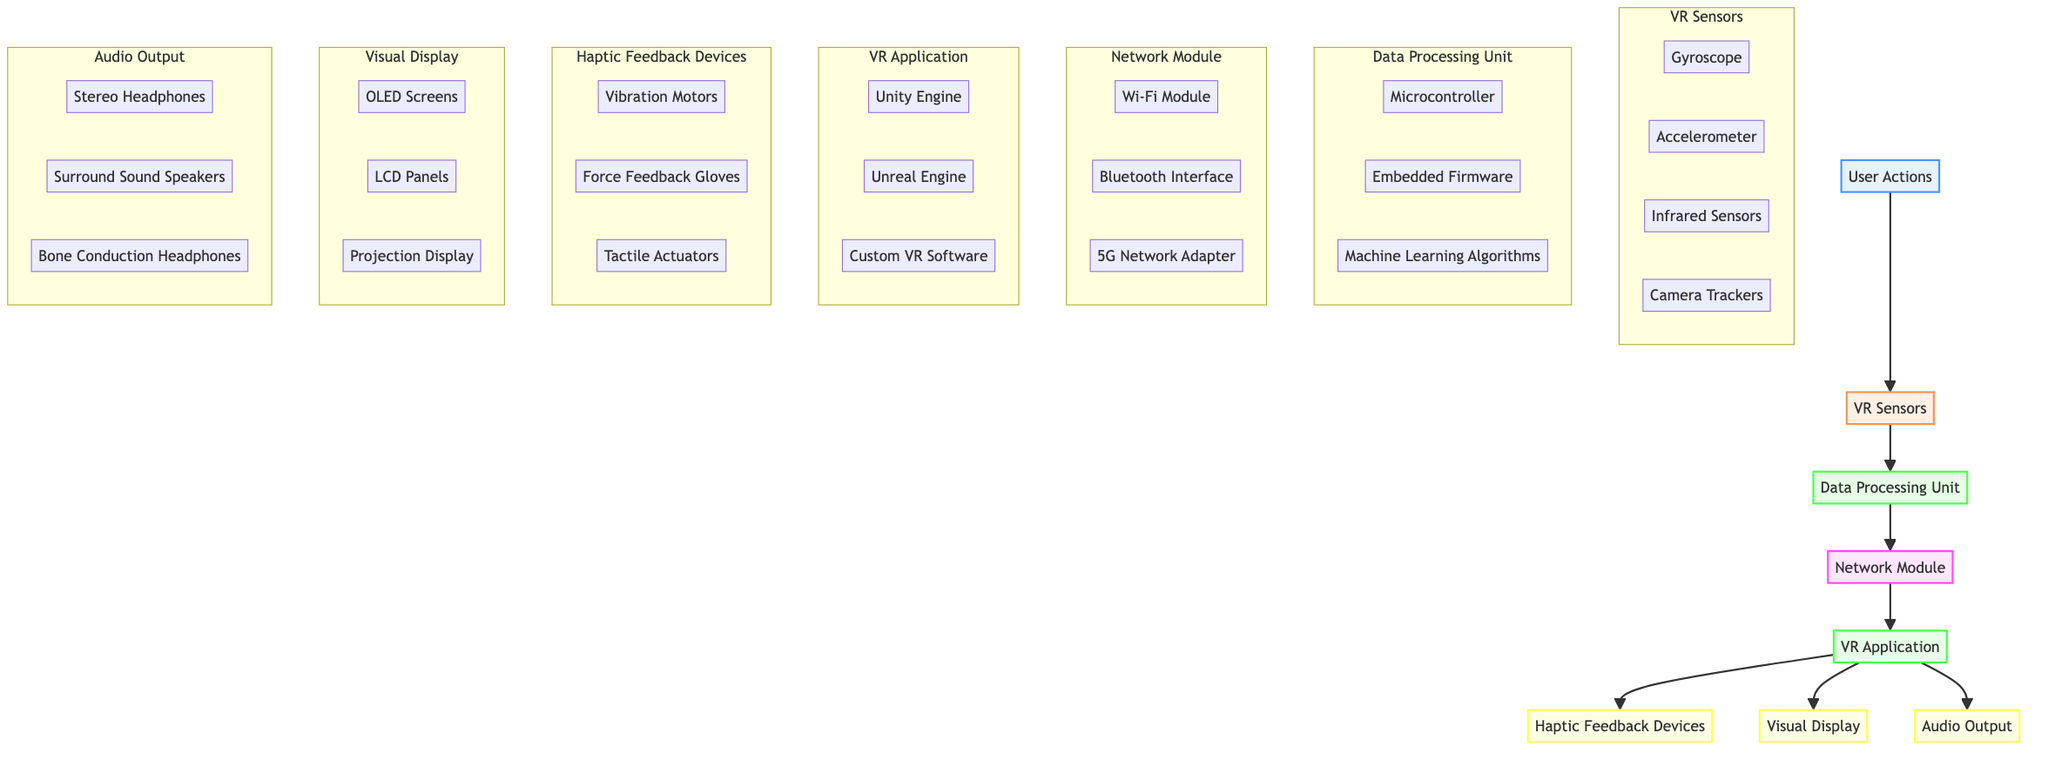What's the total number of nodes in the diagram? The diagram displays a total of 8 distinct nodes: User Actions, VR Sensors, Data Processing Unit, Network Module, VR Application, Haptic Feedback Devices, Visual Display, and Audio Output.
Answer: 8 What is the primary function of the "VR Sensors" node? According to the diagram, the "VR Sensors" node captures physical movements and gestures. This node is crucial for detecting user actions in a VR environment.
Answer: Captures physical movements How many components are there in the "Network Module"? The "Network Module" consists of three components: Wi-Fi Module, Bluetooth Interface, and 5G Network Adapter, as indicated within the node in the diagram.
Answer: 3 Which output devices are directly affected by the "VR Application"? The "VR Application" node connects directly to three output devices: Haptic Feedback Devices, Visual Display, and Audio Output, indicating that it influences all these outputs.
Answer: Haptic Feedback Devices, Visual Display, Audio Output What kind of data processing is included in the "Data Processing Unit"? The "Data Processing Unit" node includes three types of data processing components: Microcontroller, Embedded Firmware, and Machine Learning Algorithms, which are responsible for interpreting data from VR sensors.
Answer: Microcontroller, Embedded Firmware, Machine Learning Algorithms How do user actions initiate the feedback loop in the diagram? User actions are the initiating input, which flows to the "VR Sensors", indicating that these actions trigger the entire feedback loop by being the first node in the sequence.
Answer: Through VR Sensors What type of feedback does the "Haptic Feedback Devices" node provide? The diagram specifies that the "Haptic Feedback Devices" produce physical feedback, which serves to enhance the user's experience through tactile sensations in response to their actions.
Answer: Physical feedback How does the "Network Module" contribute to the user interaction feedback loop? The "Network Module" is responsible for transferring processed data between devices, which is essential for maintaining communication and real-time updates within the VR environment.
Answer: Transfers processed data What are the components listed under "Visual Display"? The "Visual Display" node includes components like OLED Screens, LCD Panels, and Projection Display, which are responsible for rendering the updated VR environment for the user.
Answer: OLED Screens, LCD Panels, Projection Display 